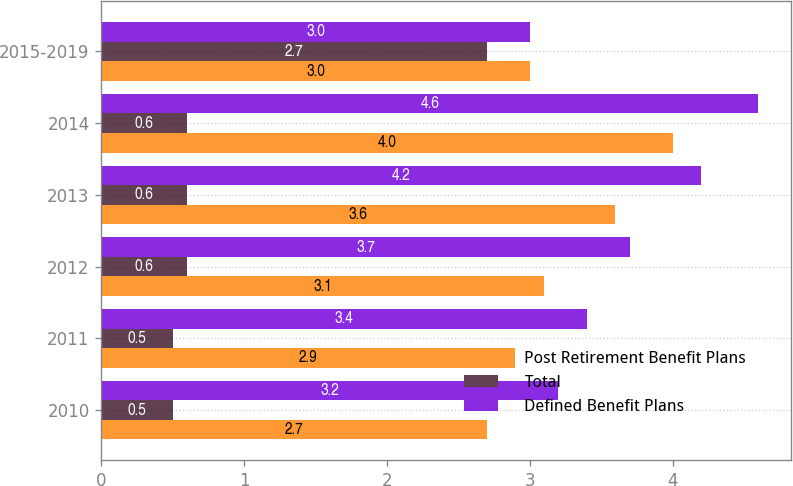<chart> <loc_0><loc_0><loc_500><loc_500><stacked_bar_chart><ecel><fcel>2010<fcel>2011<fcel>2012<fcel>2013<fcel>2014<fcel>2015-2019<nl><fcel>Post Retirement Benefit Plans<fcel>2.7<fcel>2.9<fcel>3.1<fcel>3.6<fcel>4<fcel>3<nl><fcel>Total<fcel>0.5<fcel>0.5<fcel>0.6<fcel>0.6<fcel>0.6<fcel>2.7<nl><fcel>Defined Benefit Plans<fcel>3.2<fcel>3.4<fcel>3.7<fcel>4.2<fcel>4.6<fcel>3<nl></chart> 